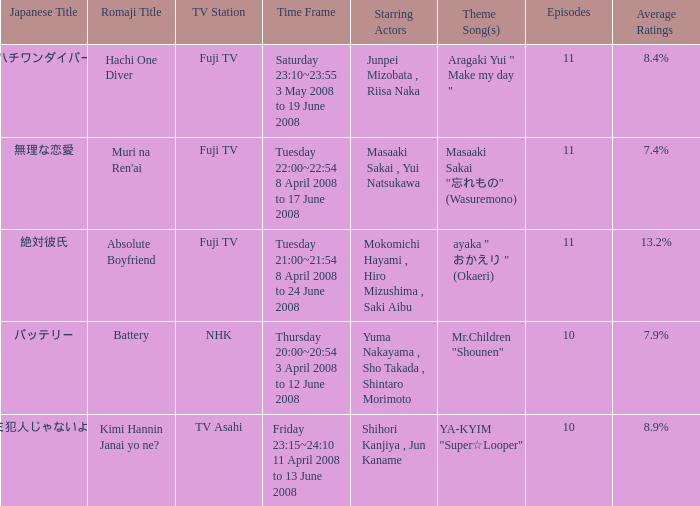What is the average rating for tv asahi? 8.9%. 